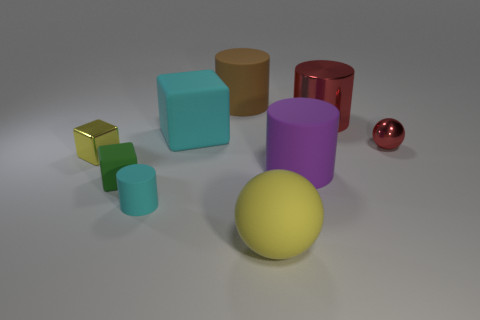Are there any large purple cylinders that have the same material as the cyan cylinder?
Your answer should be compact. Yes. There is a red cylinder that is in front of the big rubber cylinder behind the big metal cylinder; what is its material?
Keep it short and to the point. Metal. There is a cyan thing that is in front of the cyan rubber object behind the tiny object that is right of the big ball; how big is it?
Keep it short and to the point. Small. What number of other objects are there of the same shape as the small yellow thing?
Provide a short and direct response. 2. Is the color of the big object that is in front of the small rubber cube the same as the small shiny thing left of the red cylinder?
Provide a short and direct response. Yes. There is a cube that is the same size as the yellow sphere; what is its color?
Provide a short and direct response. Cyan. Are there any things of the same color as the tiny matte cylinder?
Make the answer very short. Yes. There is a rubber thing in front of the cyan matte cylinder; does it have the same size as the tiny cyan matte object?
Your response must be concise. No. Are there an equal number of cyan rubber objects that are left of the tiny green object and tiny gray matte blocks?
Offer a terse response. Yes. What number of objects are either tiny objects that are behind the green matte block or small purple things?
Offer a terse response. 2. 